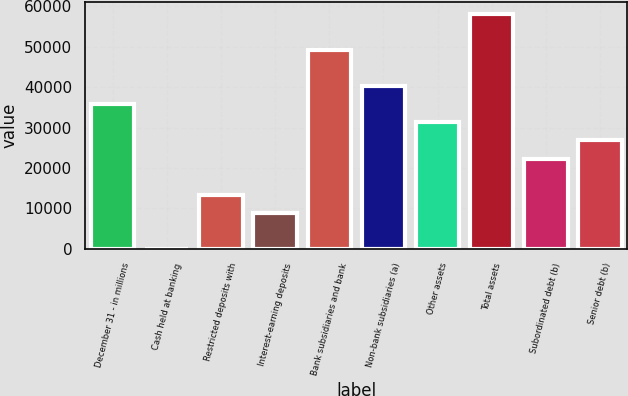<chart> <loc_0><loc_0><loc_500><loc_500><bar_chart><fcel>December 31 - in millions<fcel>Cash held at banking<fcel>Restricted deposits with<fcel>Interest-earning deposits<fcel>Bank subsidiaries and bank<fcel>Non-bank subsidiaries (a)<fcel>Other assets<fcel>Total assets<fcel>Subordinated debt (b)<fcel>Senior debt (b)<nl><fcel>35747.4<fcel>1<fcel>13405.9<fcel>8937.6<fcel>49152.3<fcel>40215.7<fcel>31279.1<fcel>58088.9<fcel>22342.5<fcel>26810.8<nl></chart> 